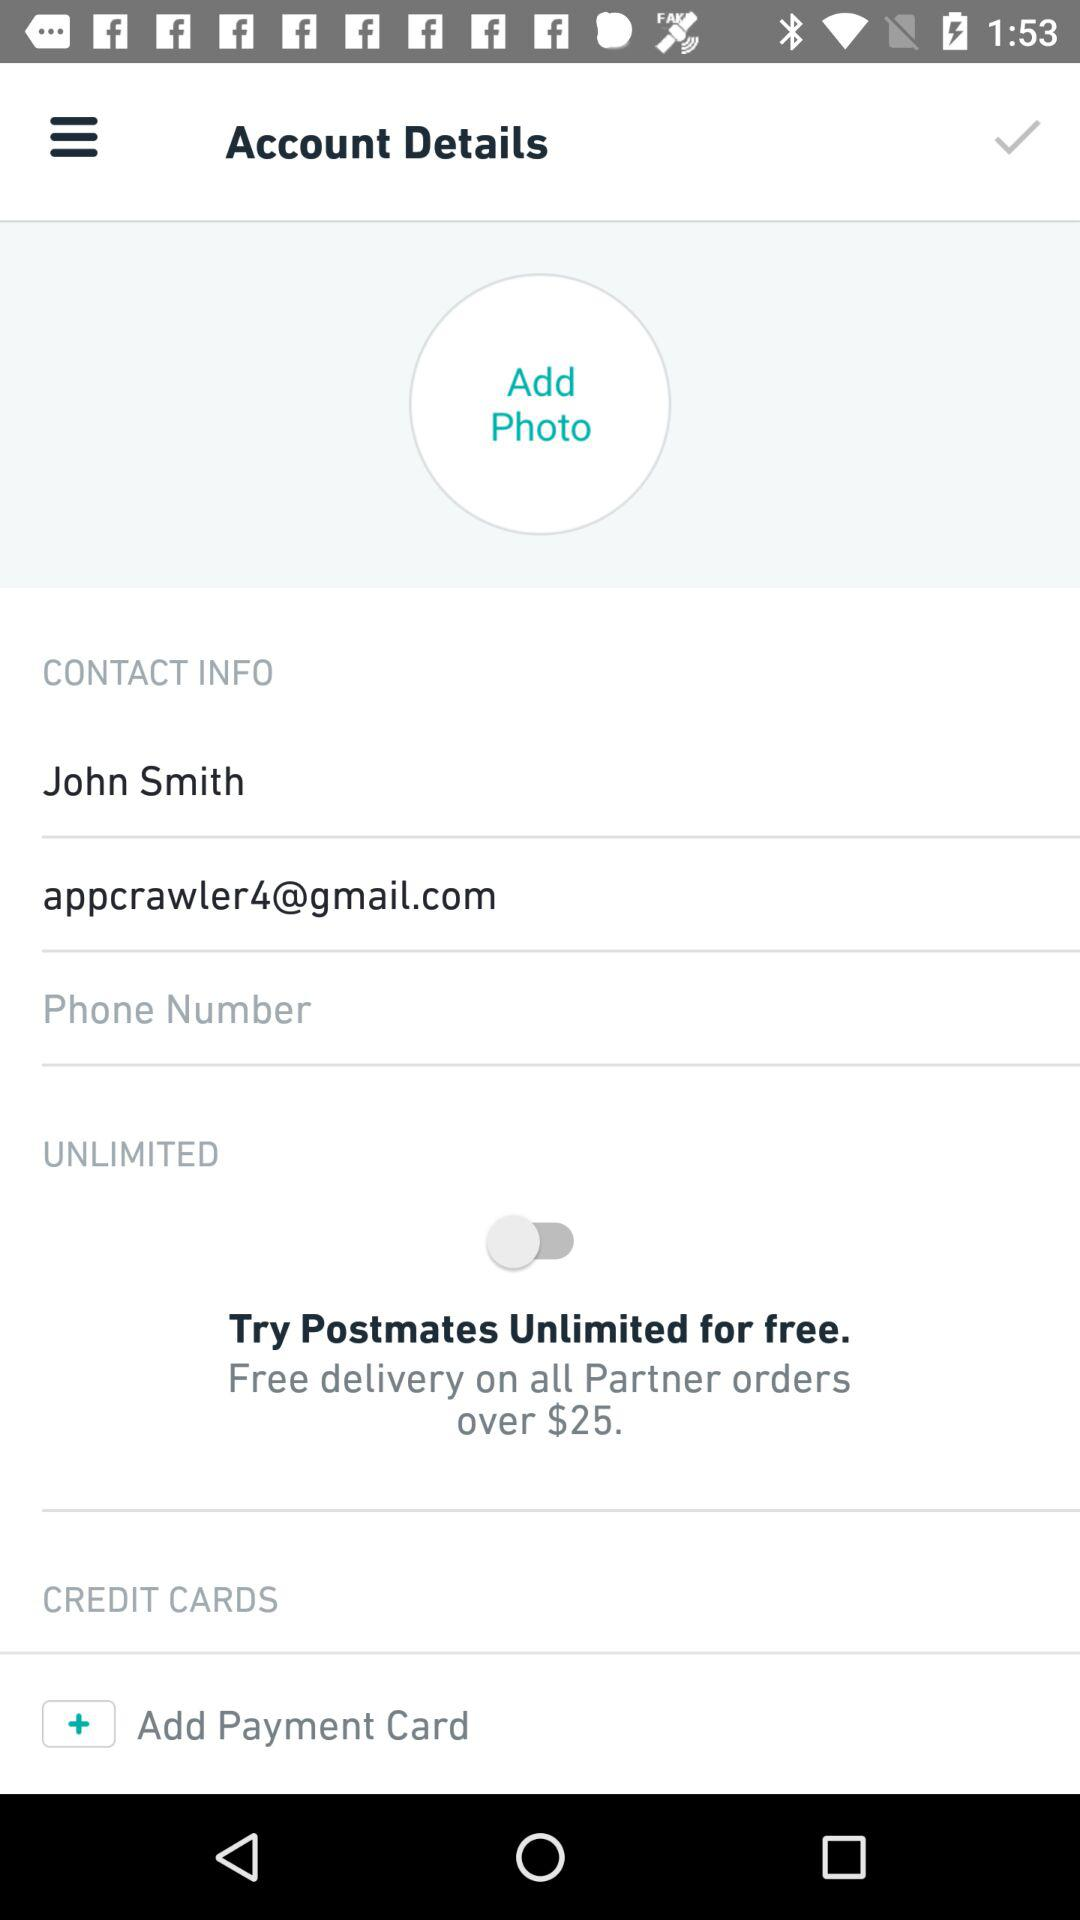What is the status of "UNLIMITED"? The status is "off". 